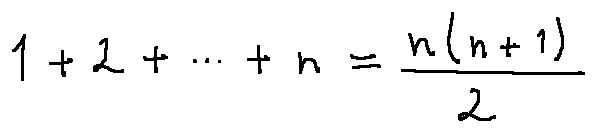Convert formula to latex. <formula><loc_0><loc_0><loc_500><loc_500>1 + 2 + \cdots + n = \frac { n ( n + 1 ) } { 2 }</formula> 